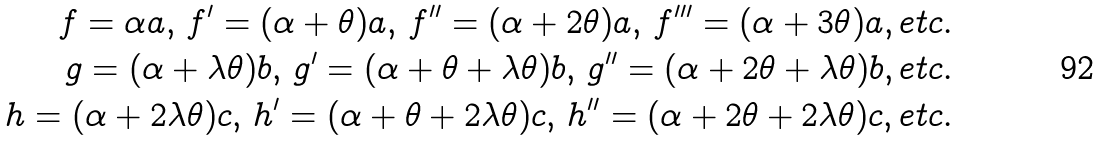Convert formula to latex. <formula><loc_0><loc_0><loc_500><loc_500>f = \alpha a , \, f ^ { \prime } = ( \alpha + \theta ) a , \, f ^ { \prime \prime } = ( \alpha + 2 \theta ) a , \, f ^ { \prime \prime \prime } = ( \alpha + 3 \theta ) a , e t c . \\ g = ( \alpha + \lambda \theta ) b , \, g ^ { \prime } = ( \alpha + \theta + \lambda \theta ) b , \, g ^ { \prime \prime } = ( \alpha + 2 \theta + \lambda \theta ) b , e t c . \\ h = ( \alpha + 2 \lambda \theta ) c , \, h ^ { \prime } = ( \alpha + \theta + 2 \lambda \theta ) c , \, h ^ { \prime \prime } = ( \alpha + 2 \theta + 2 \lambda \theta ) c , e t c .</formula> 